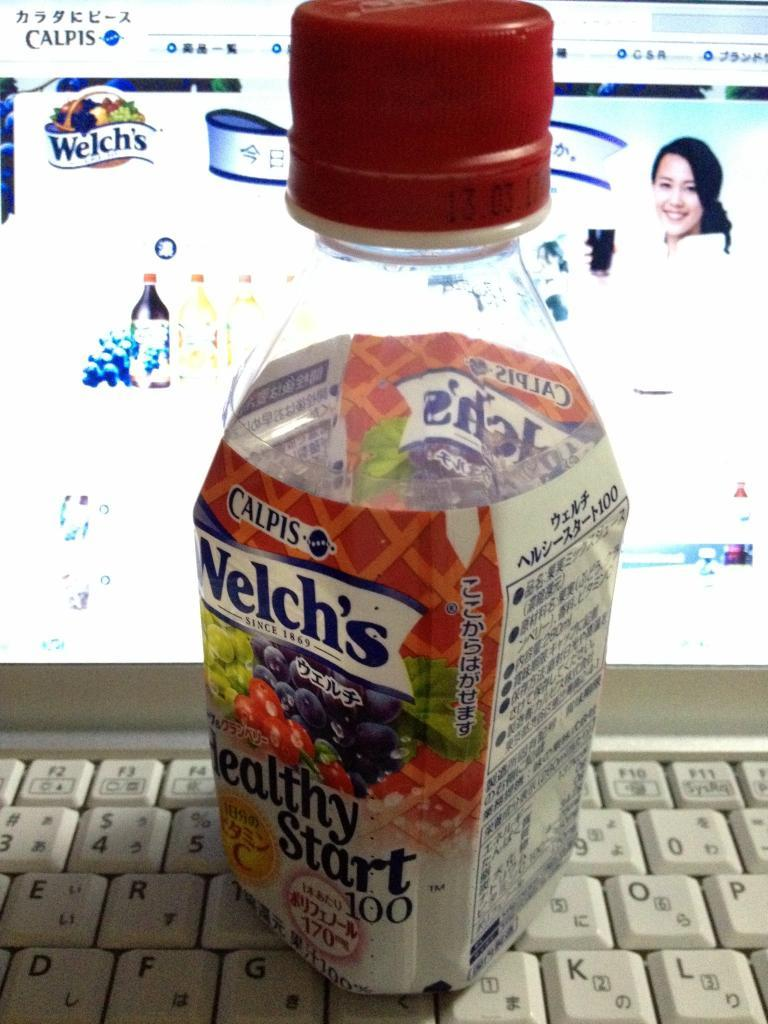<image>
Share a concise interpretation of the image provided. A bottle of Welch's healthy start 100 juice with words written in chinease. 